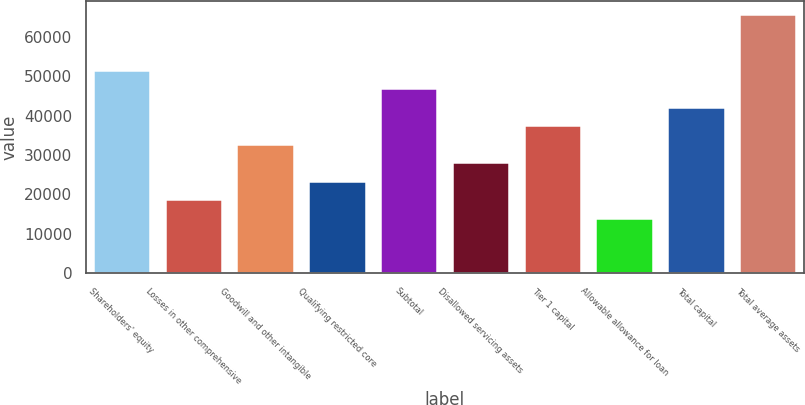Convert chart. <chart><loc_0><loc_0><loc_500><loc_500><bar_chart><fcel>Shareholders' equity<fcel>Losses in other comprehensive<fcel>Goodwill and other intangible<fcel>Qualifying restricted core<fcel>Subtotal<fcel>Disallowed servicing assets<fcel>Tier 1 capital<fcel>Allowable allowance for loan<fcel>Total capital<fcel>Total average assets<nl><fcel>51660.1<fcel>18789.1<fcel>32876.7<fcel>23485<fcel>46964.2<fcel>28180.8<fcel>37572.5<fcel>14093.2<fcel>42268.3<fcel>65747.6<nl></chart> 